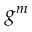<formula> <loc_0><loc_0><loc_500><loc_500>g ^ { m }</formula> 